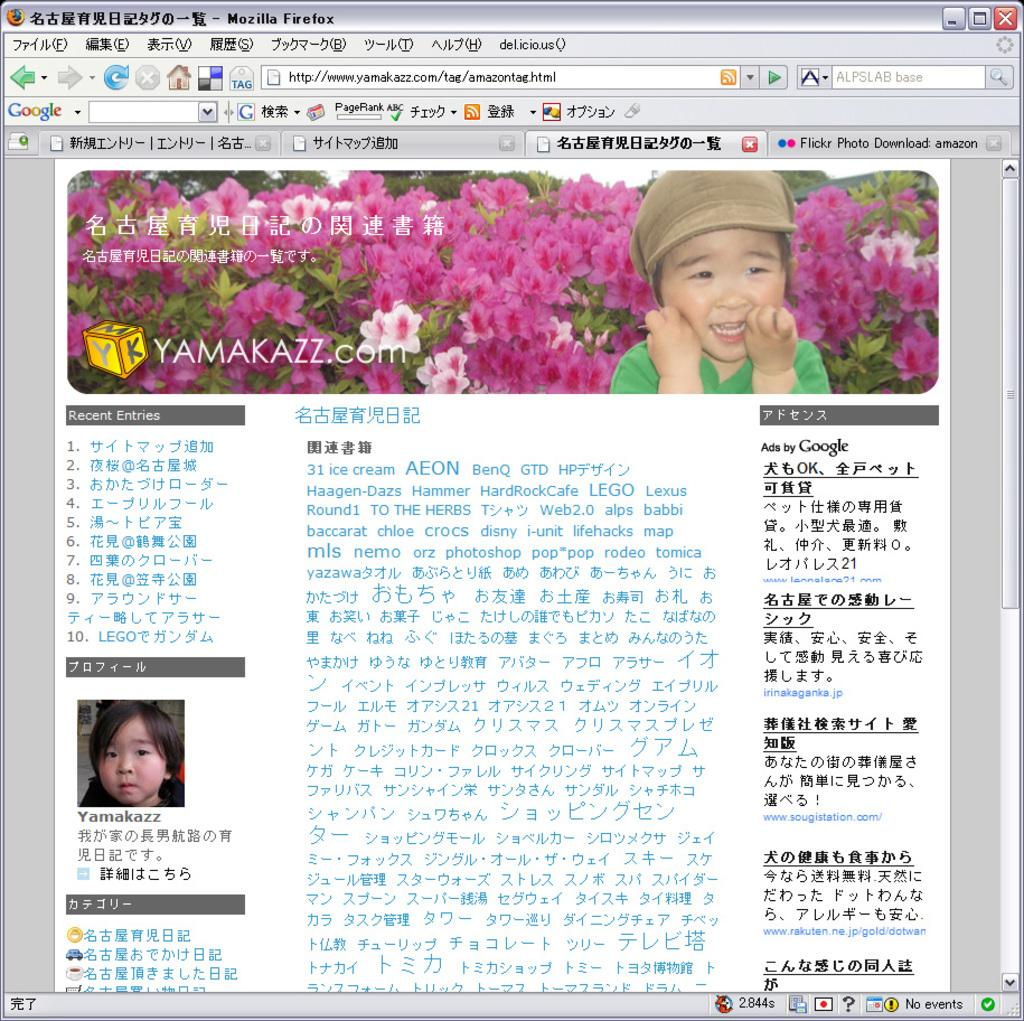What type of image is being described? The image is a screenshot. Who or what can be seen in the image? There is a kid in the image. What color are the flowers in the image? The flowers in the image are pink. What other plants are present in the image? There are plants in the image. What additional information can be found at the bottom of the image? There is text at the bottom of the image. What type of harmony can be seen between the kid and the flowers in the image? There is no indication of harmony between the kid and the flowers in the image. 